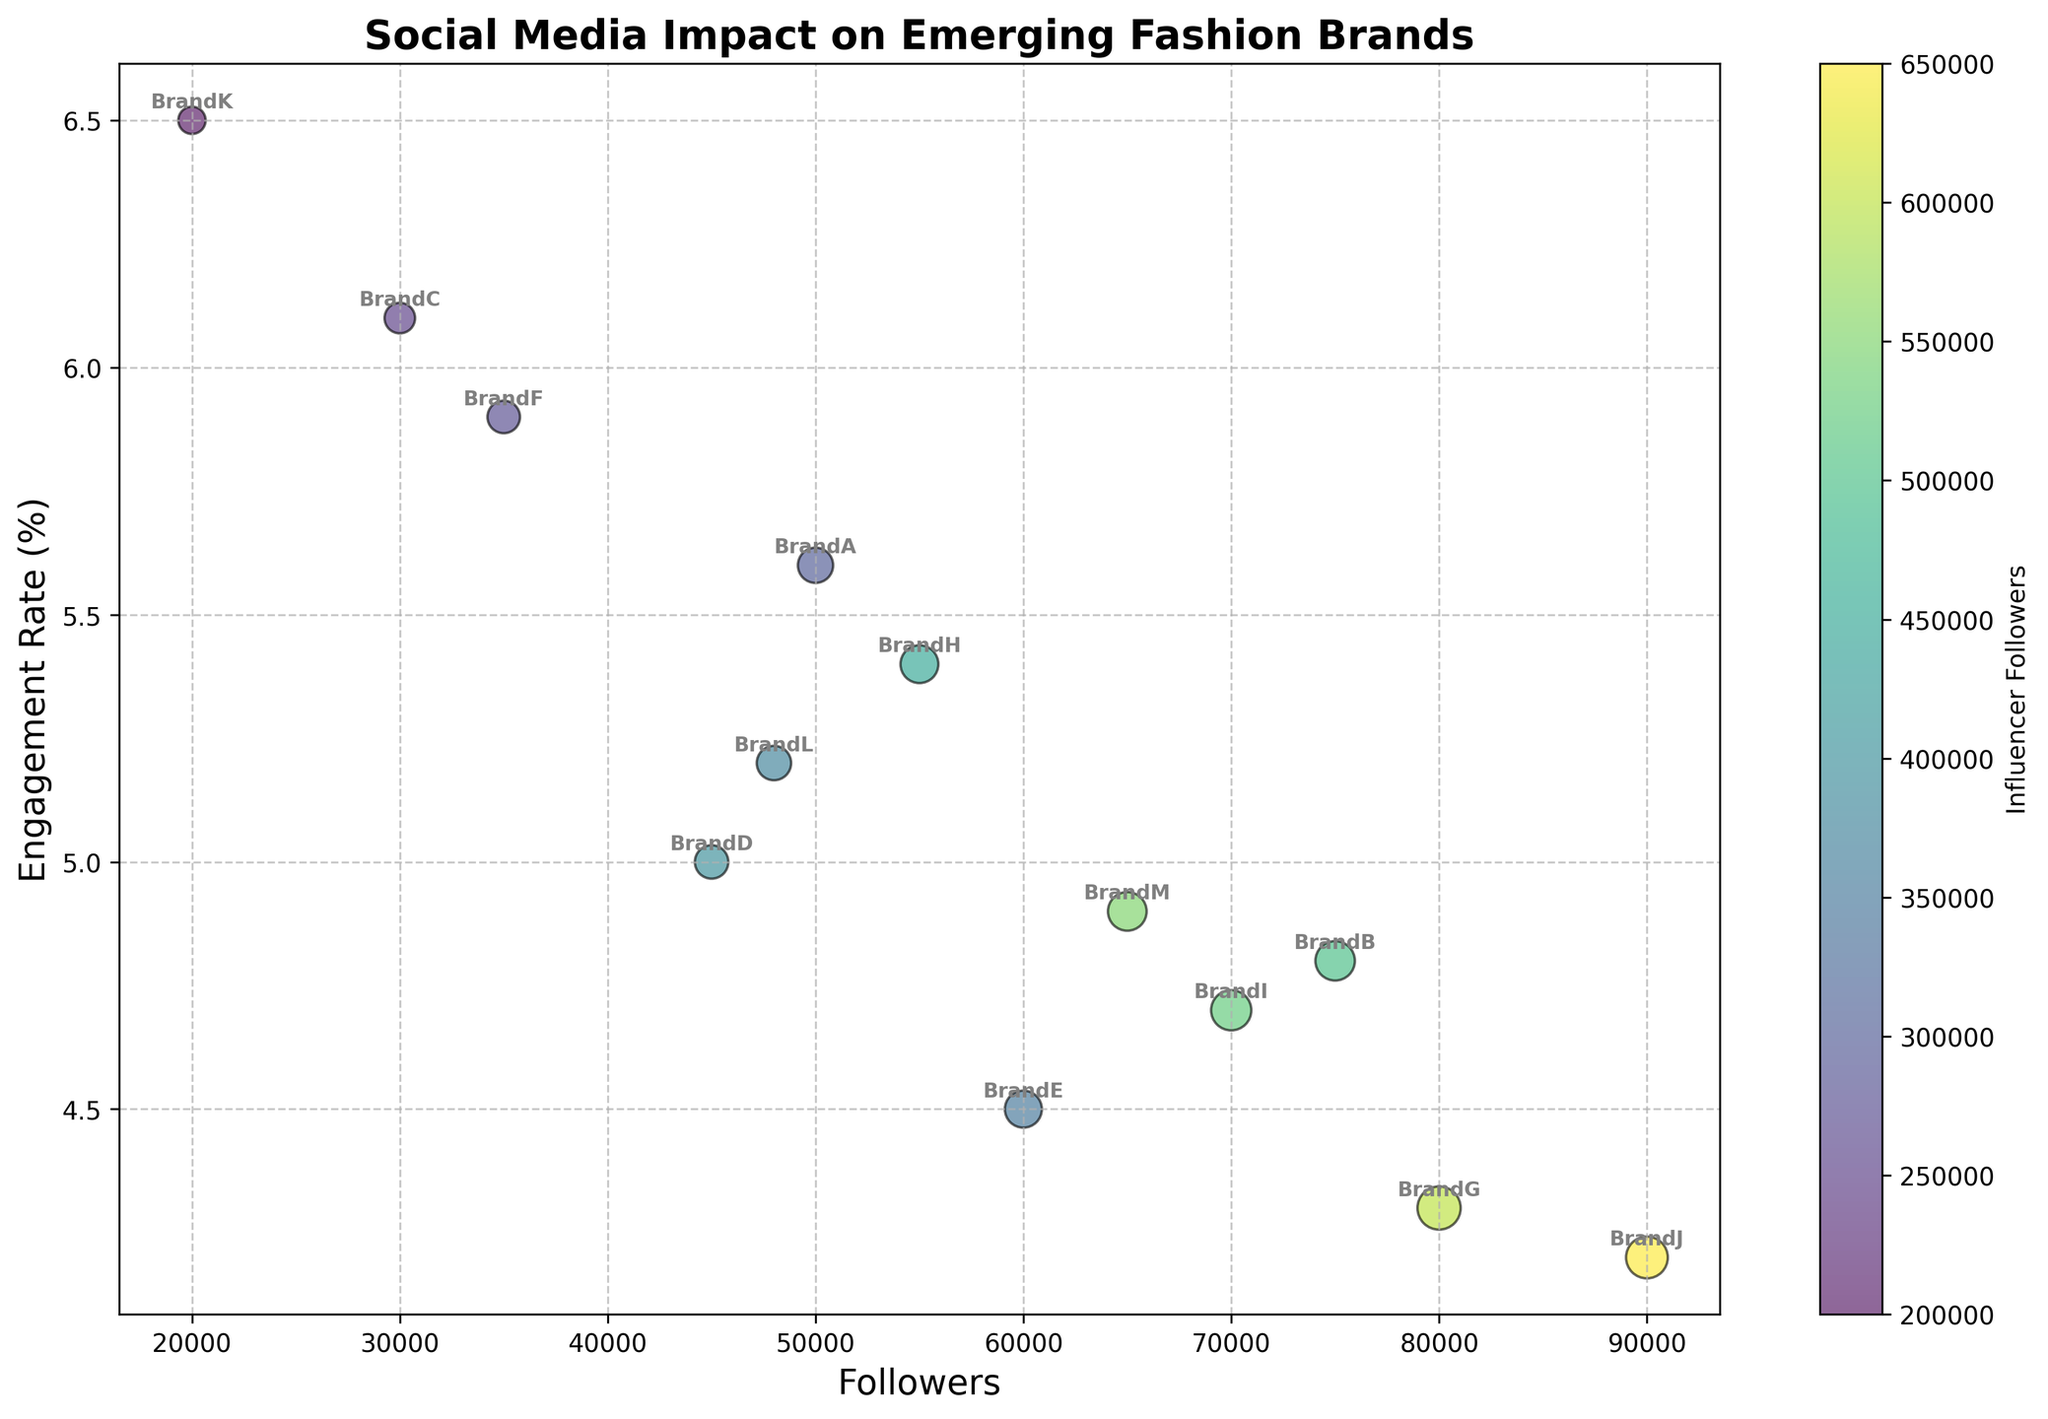What is the highest engagement rate among the brands shown in the figure? Look at the y-axis (Engagement Rate) and find the highest point on the scatter plot. Find the corresponding brand labeled near this point. The highest engagement rate is 6.5% associated with Brand K.
Answer: 6.5% Which brand has the largest number of followers? Look at the x-axis (Followers) and find the rightmost point on the scatter plot. Find the corresponding brand labeled near this point. The rightmost point corresponds to Brand J, which has 90,000 followers.
Answer: Brand J How many posts per month does Brand H have if it has an engagement rate of approximately 5.4%? Find Brand H in the plot based on the engagement rate (y-axis) of 5.4%, and then hover around the scatter point to find its size, which indicates the number of posts per month. Brand H has a medium-size spot. Cross-reference with the data: Brand H has 23 posts per month.
Answer: 23 Which key influencer has the highest influencer followers, and which brand do they associate with? Observe the colorbration indicating influencer followers. The point with the highest influencer followers will be in the darkest shade of the colorbar. Find the corresponding brand label and check the influencer. The darkest shade corresponds to Brand J with Influencer10, who has 650,000 followers.
Answer: Influencer10, Brand J What is the relationship between the number of posts per month and engagement rate for Brand G? Locate Brand G on the plot, then note its position on the y-axis (Engagement Rate) and the size of its scatter point (Posts Per Month). Brand G has an engagement rate of 4.3% and a large scatter point, indicating a high number of posts per month. Cross-reference with the data: Brand G has 30 posts per month.
Answer: 30 posts per month, 4.3% engagement rate Which brands have an engagement rate above 5% but below 6%? Identify the scatter points with y-values between 5% and 6%. Find the brands labeled near these points. The scatter points in this range correspond to Brands A, D, F, H, and L.
Answer: Brands A, D, F, H, L What is the average number of posts per month for Brands with followers between 40,000 and 60,000? Identify the brands that fall within the 40,000 to 60,000 range on the x-axis. Then, sum the number of posts per month for these brands and divide by the number of these brands. Brands in this range are A (20), D (18), E (22), H (23), and L (19). Total posts = 20 + 18 + 22 + 23 + 19 = 102. Average = 102 / 5 = 20.4
Answer: 20.4 Which influencer has the highest engagement rate, and which associated brand has the fewest followers? Look into the data points of influencers' engagement rates and cross-check with the associated brands' followers. The highest influencer engagement rate is 8.9% for Influencer11, associated with Brand K, which has the fewest followers, 20,000.
Answer: Influencer11, Brand K 